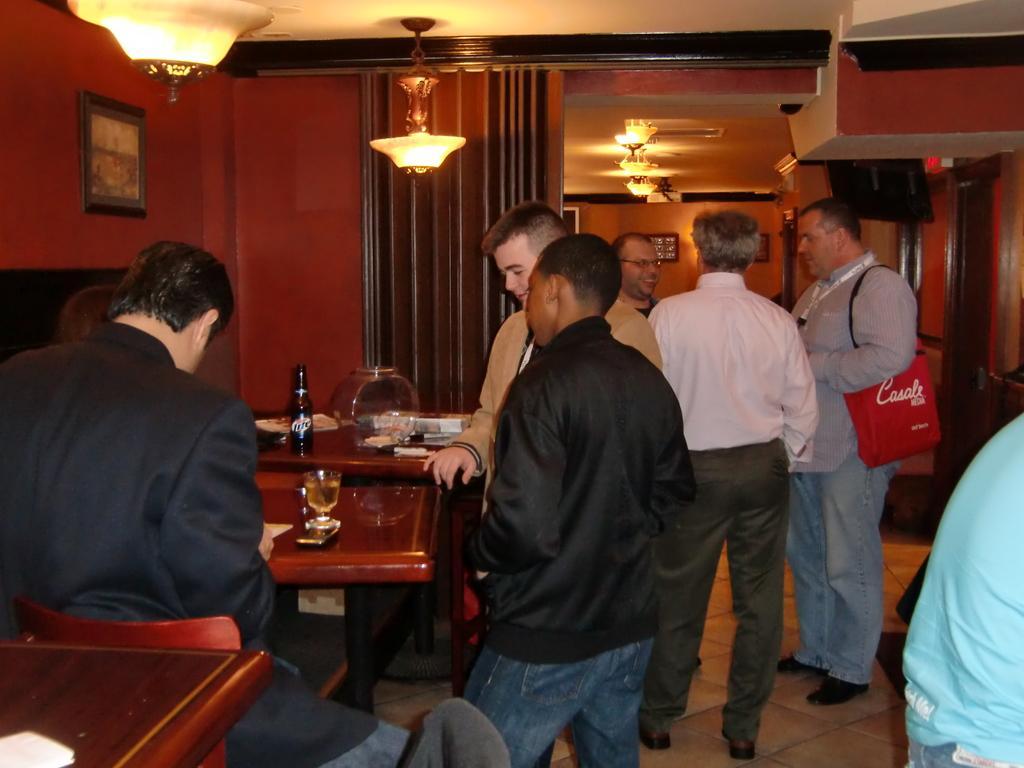Please provide a concise description of this image. There is a group of people. There is a table. There is a plate,glass on a table. On the right side we have a one person. He's wearing a bag. We can see in background curtain ,photo frame,lights. 